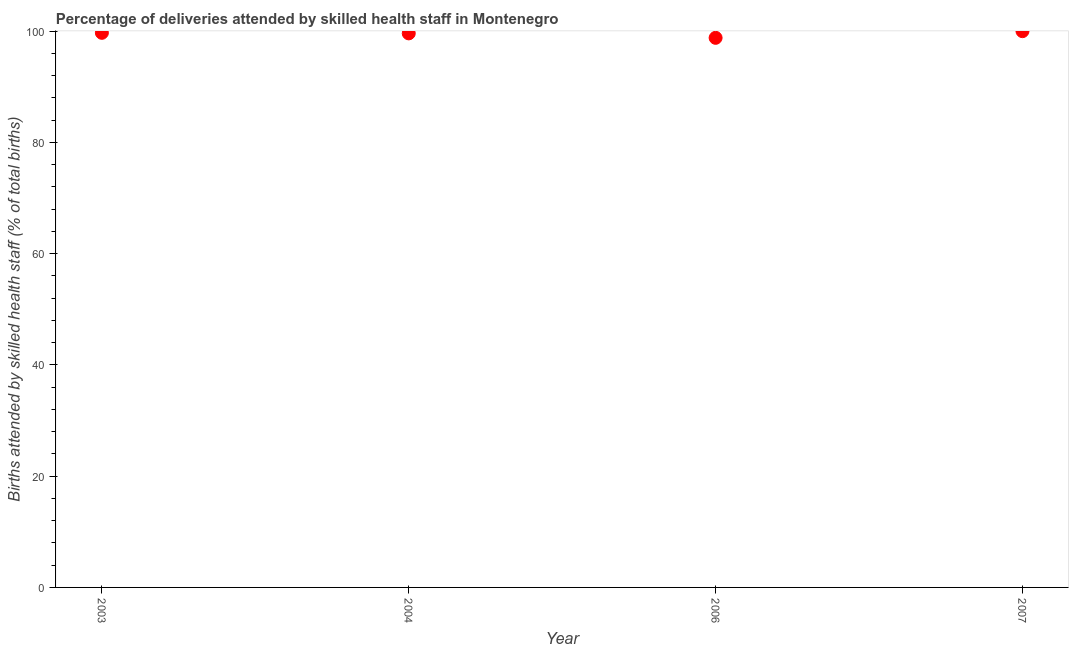What is the number of births attended by skilled health staff in 2007?
Your answer should be compact. 100. Across all years, what is the maximum number of births attended by skilled health staff?
Give a very brief answer. 100. Across all years, what is the minimum number of births attended by skilled health staff?
Ensure brevity in your answer.  98.8. What is the sum of the number of births attended by skilled health staff?
Ensure brevity in your answer.  398.1. What is the difference between the number of births attended by skilled health staff in 2003 and 2004?
Offer a very short reply. 0.1. What is the average number of births attended by skilled health staff per year?
Your answer should be very brief. 99.53. What is the median number of births attended by skilled health staff?
Keep it short and to the point. 99.65. Do a majority of the years between 2003 and 2007 (inclusive) have number of births attended by skilled health staff greater than 16 %?
Your response must be concise. Yes. What is the ratio of the number of births attended by skilled health staff in 2004 to that in 2007?
Offer a terse response. 1. Is the number of births attended by skilled health staff in 2006 less than that in 2007?
Offer a very short reply. Yes. Is the difference between the number of births attended by skilled health staff in 2004 and 2007 greater than the difference between any two years?
Provide a succinct answer. No. What is the difference between the highest and the second highest number of births attended by skilled health staff?
Offer a terse response. 0.3. Is the sum of the number of births attended by skilled health staff in 2003 and 2006 greater than the maximum number of births attended by skilled health staff across all years?
Your answer should be very brief. Yes. What is the difference between the highest and the lowest number of births attended by skilled health staff?
Offer a terse response. 1.2. In how many years, is the number of births attended by skilled health staff greater than the average number of births attended by skilled health staff taken over all years?
Your response must be concise. 3. Does the number of births attended by skilled health staff monotonically increase over the years?
Keep it short and to the point. No. How many dotlines are there?
Give a very brief answer. 1. Are the values on the major ticks of Y-axis written in scientific E-notation?
Provide a succinct answer. No. Does the graph contain any zero values?
Ensure brevity in your answer.  No. Does the graph contain grids?
Ensure brevity in your answer.  No. What is the title of the graph?
Your answer should be compact. Percentage of deliveries attended by skilled health staff in Montenegro. What is the label or title of the Y-axis?
Your answer should be very brief. Births attended by skilled health staff (% of total births). What is the Births attended by skilled health staff (% of total births) in 2003?
Provide a short and direct response. 99.7. What is the Births attended by skilled health staff (% of total births) in 2004?
Your answer should be very brief. 99.6. What is the Births attended by skilled health staff (% of total births) in 2006?
Offer a very short reply. 98.8. What is the difference between the Births attended by skilled health staff (% of total births) in 2003 and 2004?
Provide a short and direct response. 0.1. What is the difference between the Births attended by skilled health staff (% of total births) in 2003 and 2006?
Make the answer very short. 0.9. What is the difference between the Births attended by skilled health staff (% of total births) in 2004 and 2006?
Offer a terse response. 0.8. What is the difference between the Births attended by skilled health staff (% of total births) in 2004 and 2007?
Your response must be concise. -0.4. What is the ratio of the Births attended by skilled health staff (% of total births) in 2003 to that in 2004?
Ensure brevity in your answer.  1. What is the ratio of the Births attended by skilled health staff (% of total births) in 2003 to that in 2007?
Make the answer very short. 1. What is the ratio of the Births attended by skilled health staff (% of total births) in 2004 to that in 2006?
Your answer should be very brief. 1.01. 